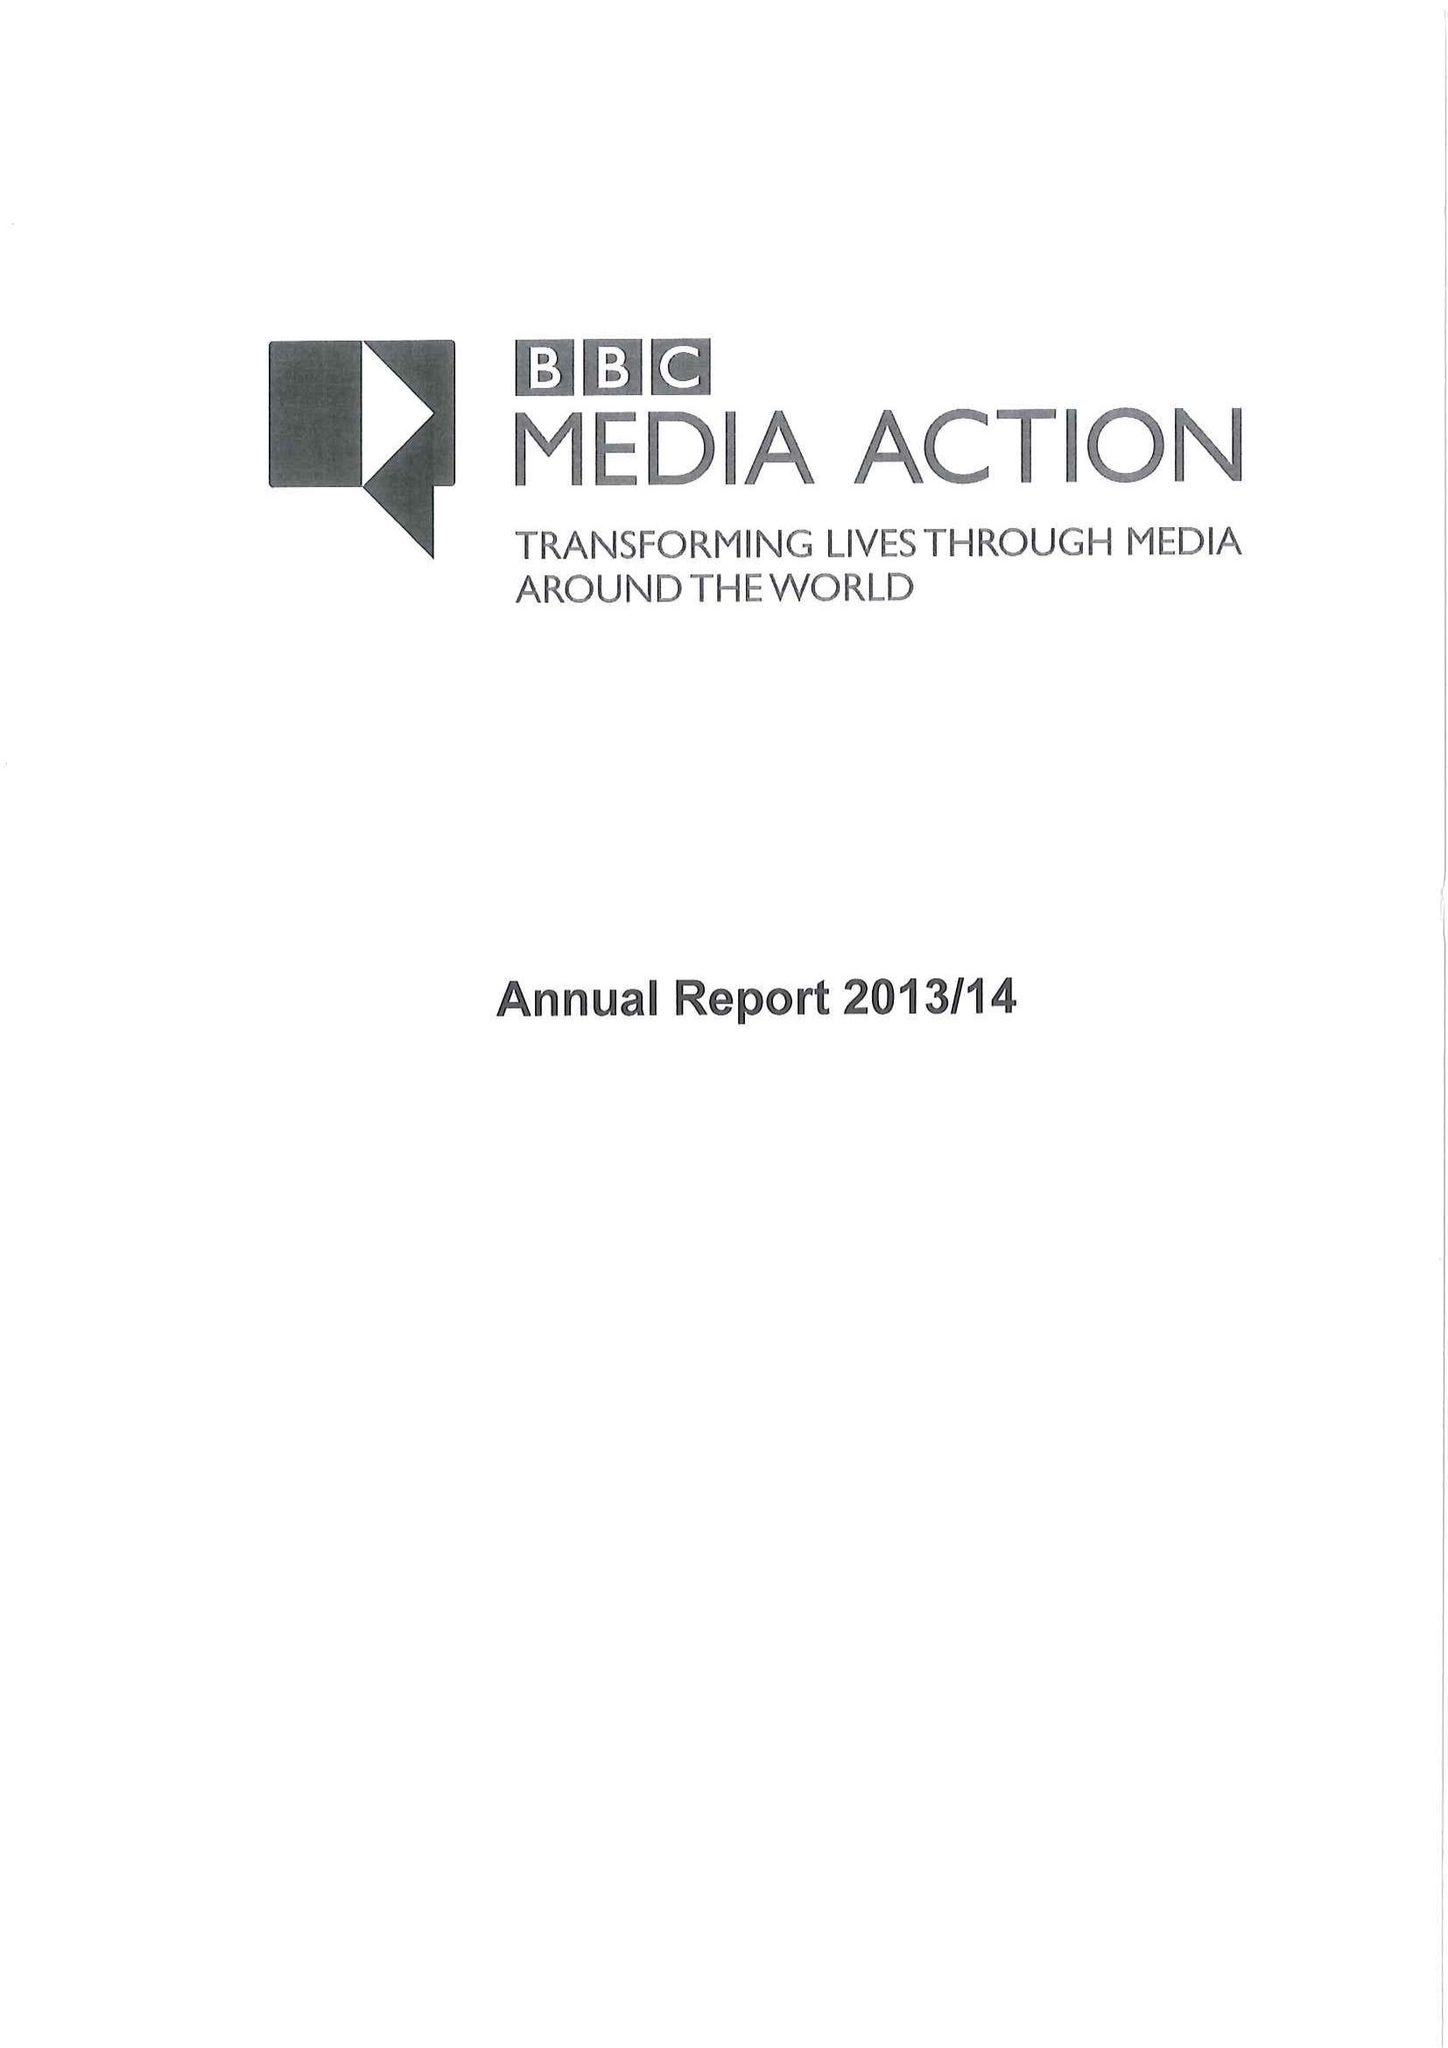What is the value for the charity_name?
Answer the question using a single word or phrase. Bbc Media Action 